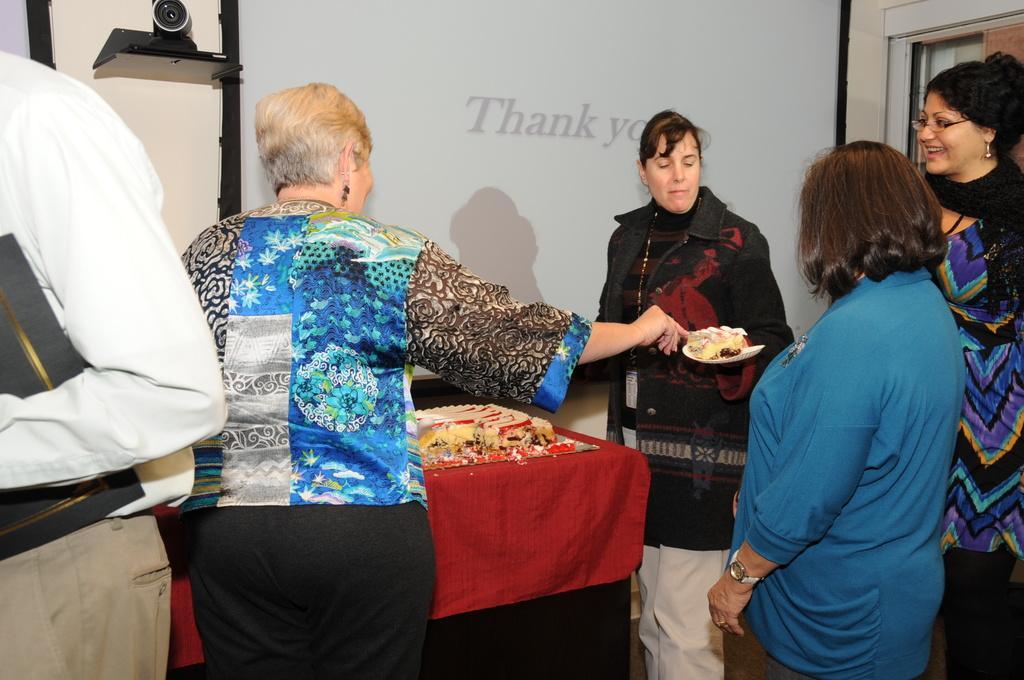Could you give a brief overview of what you see in this image? In this image, we can see persons wearing clothes and standing in front of the screen. There is a table at the bottom of the image contains a cake. There is a person in the middle of the image holding a cake with her hand. There is a camera in the top left of the image. There is an another person on the left side of the image. 